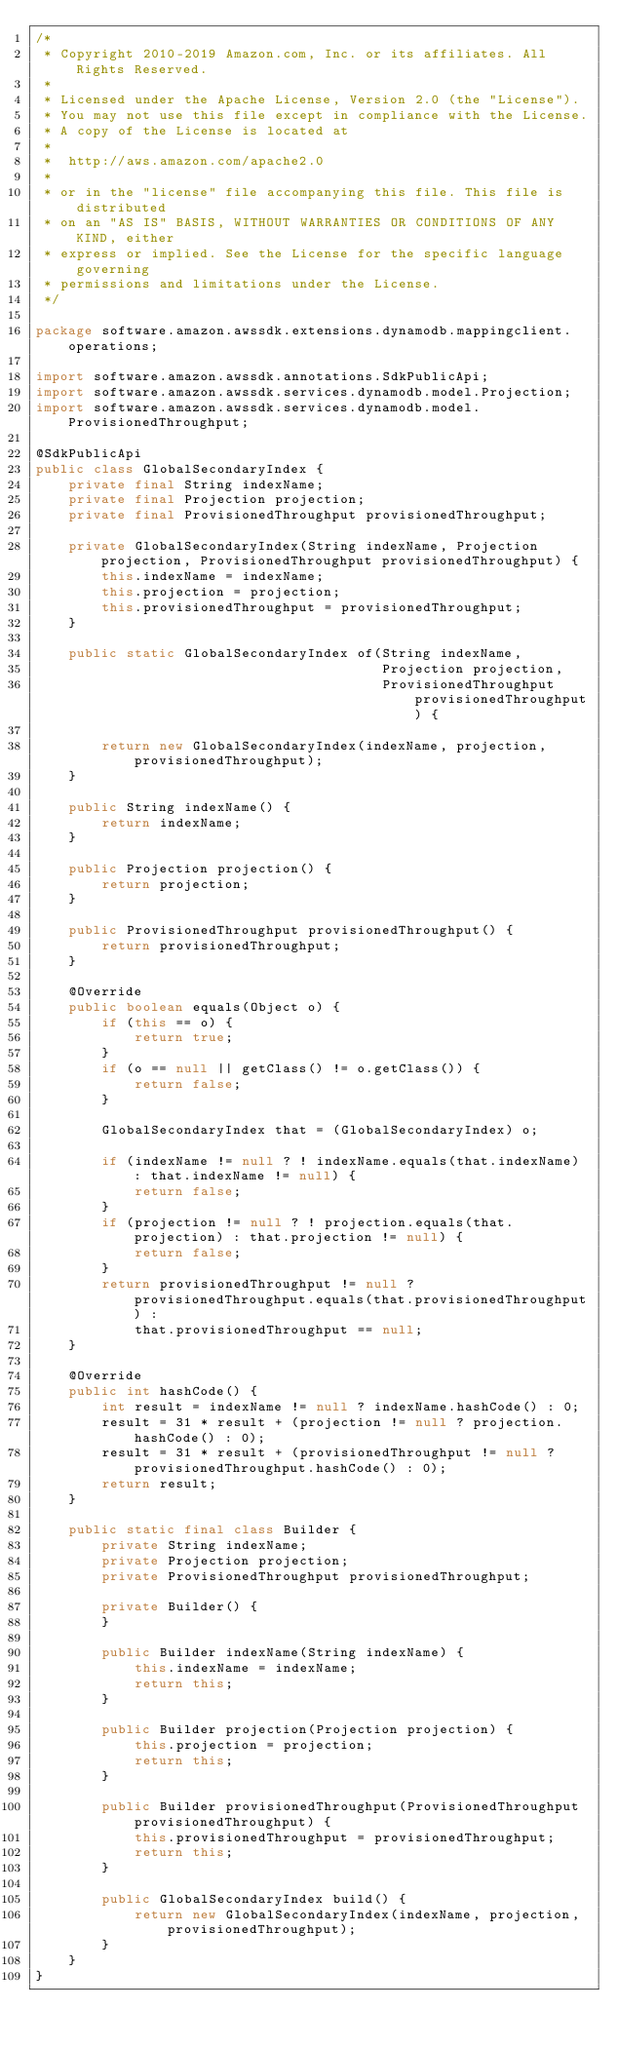<code> <loc_0><loc_0><loc_500><loc_500><_Java_>/*
 * Copyright 2010-2019 Amazon.com, Inc. or its affiliates. All Rights Reserved.
 *
 * Licensed under the Apache License, Version 2.0 (the "License").
 * You may not use this file except in compliance with the License.
 * A copy of the License is located at
 *
 *  http://aws.amazon.com/apache2.0
 *
 * or in the "license" file accompanying this file. This file is distributed
 * on an "AS IS" BASIS, WITHOUT WARRANTIES OR CONDITIONS OF ANY KIND, either
 * express or implied. See the License for the specific language governing
 * permissions and limitations under the License.
 */

package software.amazon.awssdk.extensions.dynamodb.mappingclient.operations;

import software.amazon.awssdk.annotations.SdkPublicApi;
import software.amazon.awssdk.services.dynamodb.model.Projection;
import software.amazon.awssdk.services.dynamodb.model.ProvisionedThroughput;

@SdkPublicApi
public class GlobalSecondaryIndex {
    private final String indexName;
    private final Projection projection;
    private final ProvisionedThroughput provisionedThroughput;

    private GlobalSecondaryIndex(String indexName, Projection projection, ProvisionedThroughput provisionedThroughput) {
        this.indexName = indexName;
        this.projection = projection;
        this.provisionedThroughput = provisionedThroughput;
    }

    public static GlobalSecondaryIndex of(String indexName,
                                          Projection projection,
                                          ProvisionedThroughput provisionedThroughput) {

        return new GlobalSecondaryIndex(indexName, projection, provisionedThroughput);
    }

    public String indexName() {
        return indexName;
    }

    public Projection projection() {
        return projection;
    }

    public ProvisionedThroughput provisionedThroughput() {
        return provisionedThroughput;
    }

    @Override
    public boolean equals(Object o) {
        if (this == o) {
            return true;
        }
        if (o == null || getClass() != o.getClass()) {
            return false;
        }

        GlobalSecondaryIndex that = (GlobalSecondaryIndex) o;

        if (indexName != null ? ! indexName.equals(that.indexName) : that.indexName != null) {
            return false;
        }
        if (projection != null ? ! projection.equals(that.projection) : that.projection != null) {
            return false;
        }
        return provisionedThroughput != null ? provisionedThroughput.equals(that.provisionedThroughput) :
            that.provisionedThroughput == null;
    }

    @Override
    public int hashCode() {
        int result = indexName != null ? indexName.hashCode() : 0;
        result = 31 * result + (projection != null ? projection.hashCode() : 0);
        result = 31 * result + (provisionedThroughput != null ? provisionedThroughput.hashCode() : 0);
        return result;
    }

    public static final class Builder {
        private String indexName;
        private Projection projection;
        private ProvisionedThroughput provisionedThroughput;

        private Builder() {
        }

        public Builder indexName(String indexName) {
            this.indexName = indexName;
            return this;
        }

        public Builder projection(Projection projection) {
            this.projection = projection;
            return this;
        }

        public Builder provisionedThroughput(ProvisionedThroughput provisionedThroughput) {
            this.provisionedThroughput = provisionedThroughput;
            return this;
        }

        public GlobalSecondaryIndex build() {
            return new GlobalSecondaryIndex(indexName, projection, provisionedThroughput);
        }
    }
}
</code> 